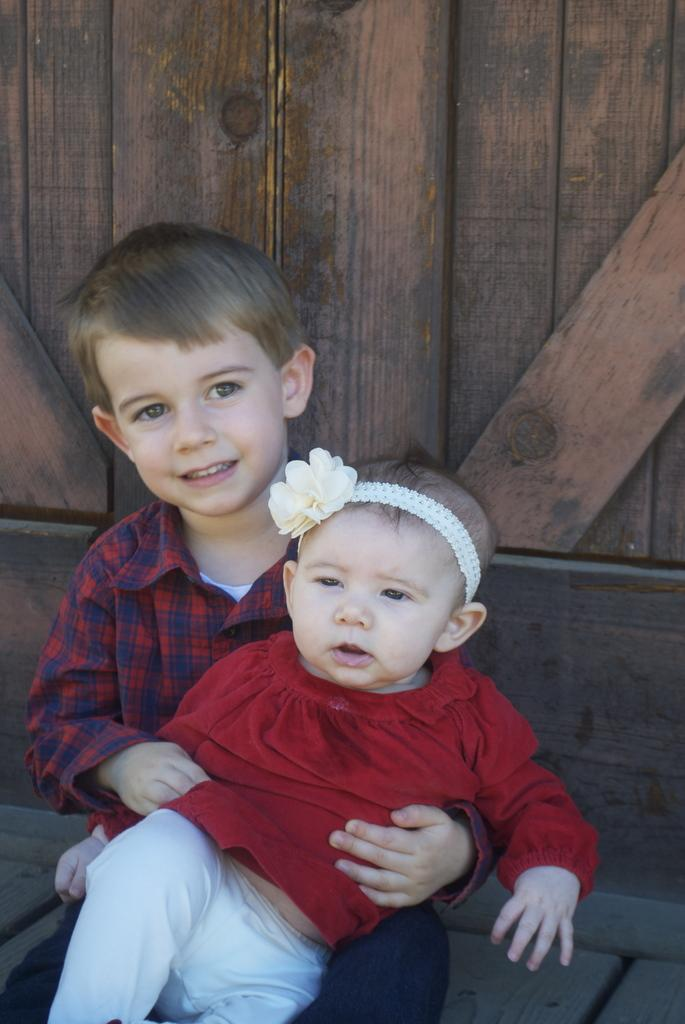Who is the main subject in the image? There is a boy in the image. What is the boy doing in the image? There is a baby sitting on the boy. What can be seen behind the boy and baby? There is a wooden background in the image. Is there a river flowing in the background of the image? No, there is no river visible in the image. The background is made of wood, as mentioned in the conversation. 